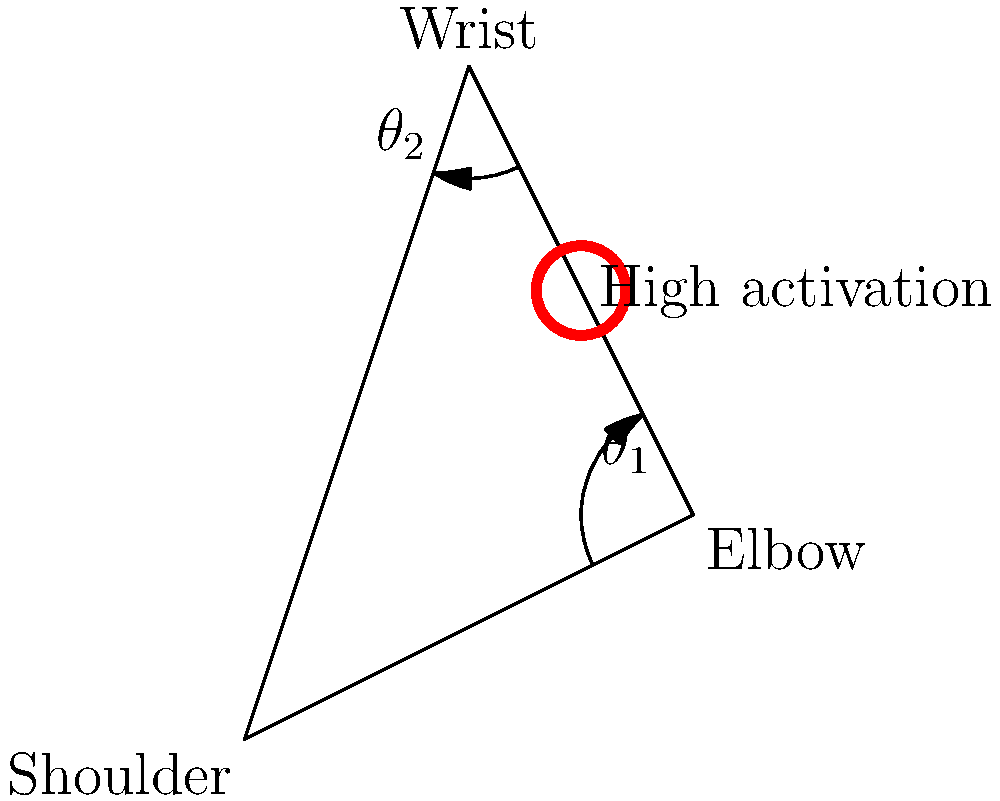In a typical welding posture, the shoulder-elbow-wrist system forms a triangle as shown in the diagram. If the elbow angle ($\theta_1$) is 120° and the wrist angle ($\theta_2$) is 150°, what is the shoulder angle? Assume that the internal angles of a triangle always sum to 180°. To find the shoulder angle, we can follow these steps:

1. Recall that the sum of internal angles in a triangle is always 180°.

2. We are given two angles in the triangle:
   - Elbow angle ($\theta_1$) = 120°
   - Wrist angle ($\theta_2$) = 150°

3. Let's call the shoulder angle $\theta_s$.

4. We can set up an equation based on the fact that all angles in a triangle sum to 180°:

   $$\theta_s + \theta_1 + \theta_2 = 180°$$

5. Substitute the known values:

   $$\theta_s + 120° + 150° = 180°$$

6. Simplify:

   $$\theta_s + 270° = 180°$$

7. Subtract 270° from both sides:

   $$\theta_s = 180° - 270° = -90°$$

8. Since angles in geometry are typically expressed as positive values, we can add 360° to get the equivalent positive angle:

   $$\theta_s = -90° + 360° = 270°$$

Therefore, the shoulder angle in this welding posture is 270°.
Answer: 270° 